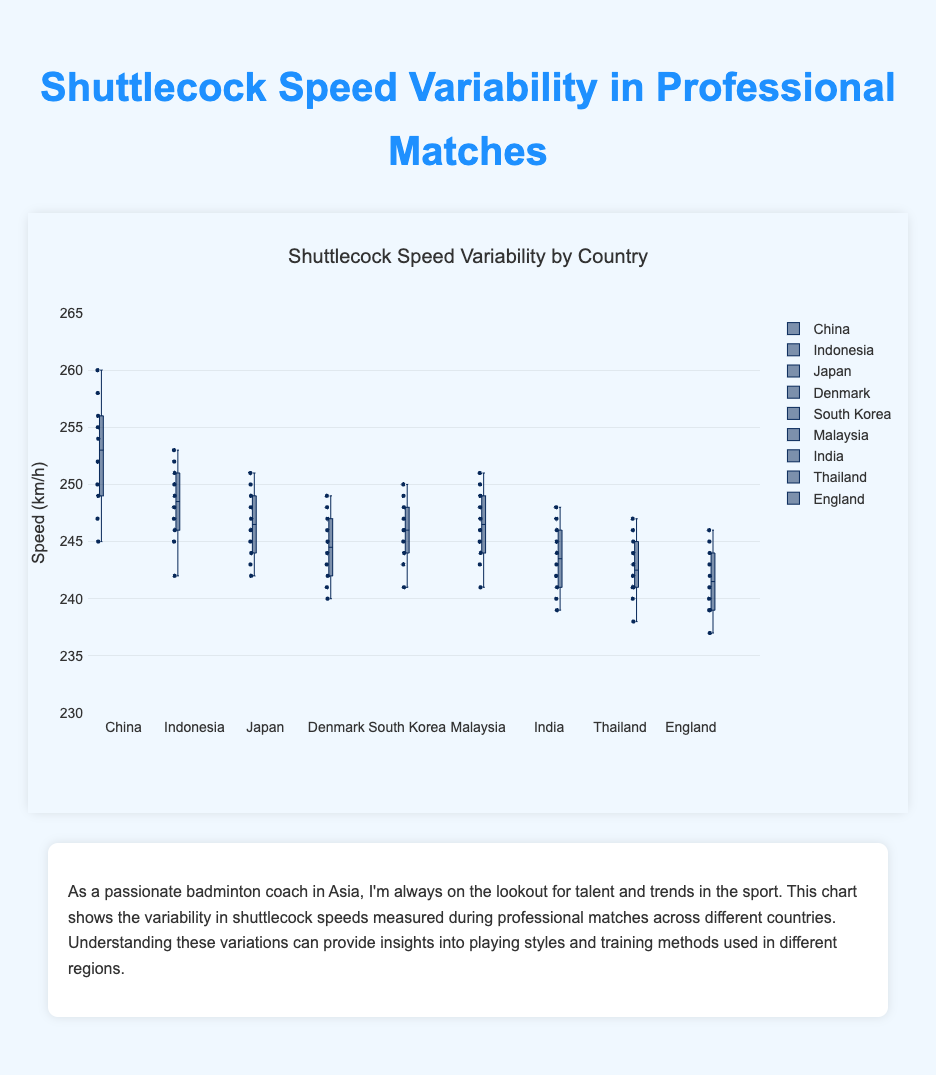What is the title of the figure? The title is usually found at the top of the figure, summarizing the main content.
Answer: Shuttlecock Speed Variability by Country Which country has the highest range of shuttlecock speeds? The range is the difference between the maximum and minimum values. Look for the country with the widest spread between its box plot whiskers.
Answer: China What is the median shuttlecock speed for Japan? The median is the line inside the box. For Japan, find the value of this line.
Answer: 246 Which country has the most consistent shuttlecock speeds? Consistency can be measured by the smallest interquartile range (IQR), the height of the box. Look for the shortest box.
Answer: England How many countries have a median speed above 245 km/h? Count the number of box plots where the median line is above the 245 km/h mark on the y-axis.
Answer: 6 Which country has the lowest median shuttlecock speed? Locate the median line for each country and find the country with the lowest median value.
Answer: England For South Korea, what is the speed range between the first and third quartiles? The first quartile is the bottom of the box, and the third quartile is the top. Subtract the first quartile from the third quartile.
Answer: 6 km/h (246 to 252) Compare the medians of China and Indonesia. Which is higher? Identify the median lines for both China and Indonesia and compare their values.
Answer: China What is the interquartile range (IQR) for Denmark? The IQR is the distance between the third quartile (top of the box) and the first quartile (bottom of the box). Calculate this difference.
Answer: 5 km/h Are there any outliers in Malaysia's shuttlecock speeds? Outliers are typically data points that fall outside the whiskers. Check Malaysia's box plot for any individual points outside the whiskers.
Answer: No What is the approximate lowest shuttlecock speed recorded in Thailand? The lowest value is at the bottom whisker or the lowest point outside the whisker. Find this position on Thailand's box plot.
Answer: 238 km/h 